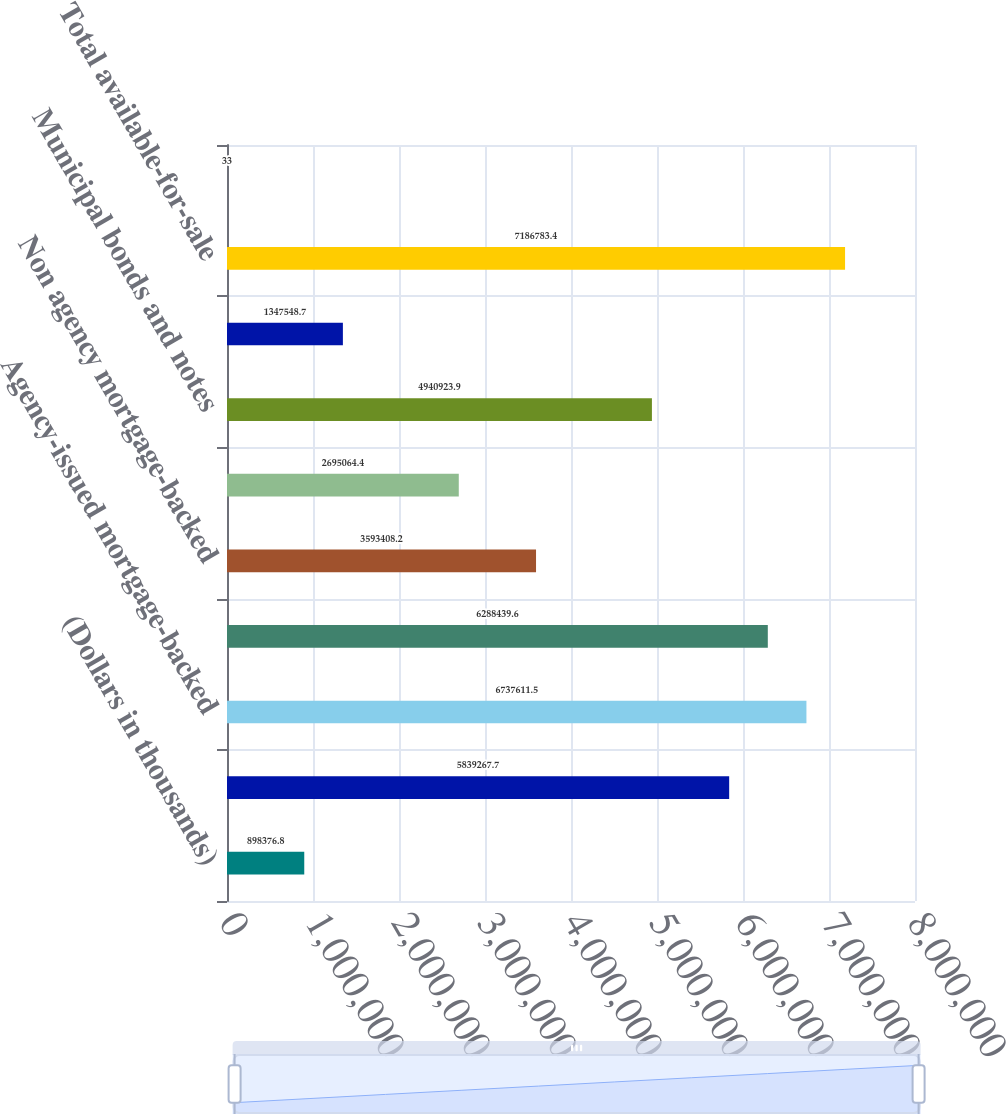Convert chart. <chart><loc_0><loc_0><loc_500><loc_500><bar_chart><fcel>(Dollars in thousands)<fcel>US agency debentures<fcel>Agency-issued mortgage-backed<fcel>Agency-issued collateralized<fcel>Non agency mortgage-backed<fcel>Commercial mortgage-backed<fcel>Municipal bonds and notes<fcel>Marketable equity securities<fcel>Total available-for-sale<fcel>Marketable securities<nl><fcel>898377<fcel>5.83927e+06<fcel>6.73761e+06<fcel>6.28844e+06<fcel>3.59341e+06<fcel>2.69506e+06<fcel>4.94092e+06<fcel>1.34755e+06<fcel>7.18678e+06<fcel>33<nl></chart> 